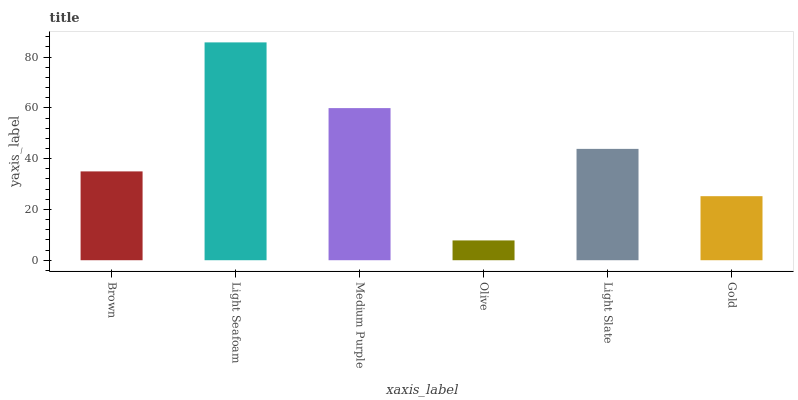Is Olive the minimum?
Answer yes or no. Yes. Is Light Seafoam the maximum?
Answer yes or no. Yes. Is Medium Purple the minimum?
Answer yes or no. No. Is Medium Purple the maximum?
Answer yes or no. No. Is Light Seafoam greater than Medium Purple?
Answer yes or no. Yes. Is Medium Purple less than Light Seafoam?
Answer yes or no. Yes. Is Medium Purple greater than Light Seafoam?
Answer yes or no. No. Is Light Seafoam less than Medium Purple?
Answer yes or no. No. Is Light Slate the high median?
Answer yes or no. Yes. Is Brown the low median?
Answer yes or no. Yes. Is Medium Purple the high median?
Answer yes or no. No. Is Medium Purple the low median?
Answer yes or no. No. 